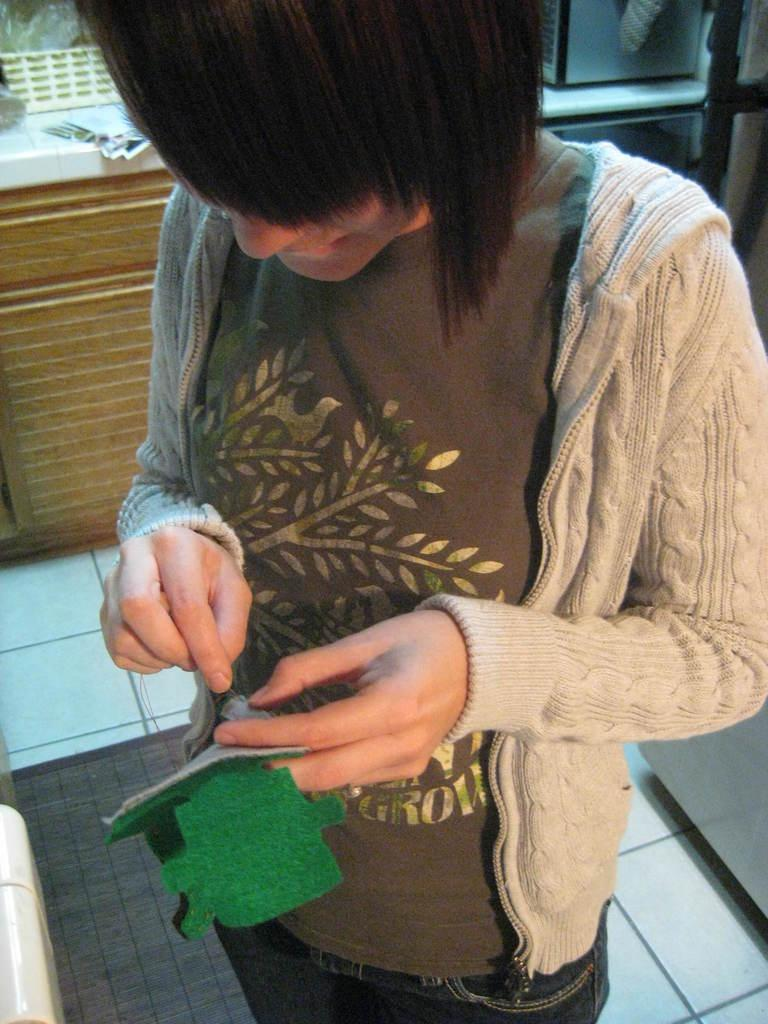Who is present in the image? There is a woman in the image. What is the woman holding in her hand? The woman is holding a cloth in her hand. What can be seen on the floor in the image? There is a doormat on the floor. What is on the countertop in the image? There are papers and a basket on the countertop. What type of goat can be seen distributing papers in the image? There is no goat present in the image, and therefore no such activity can be observed. 